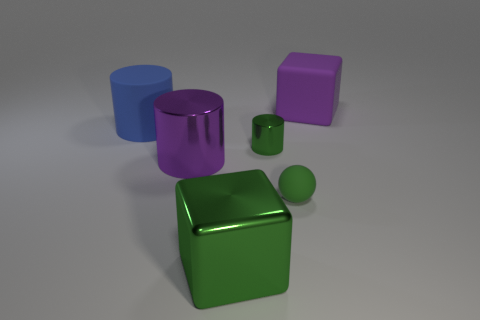Are these objects arranged in some specific pattern or sequence? The objects are not arranged in a regular pattern or sequence; they appear to be placed randomly on a flat surface. They vary in size and are spaced apart from one another with no apparent order. 